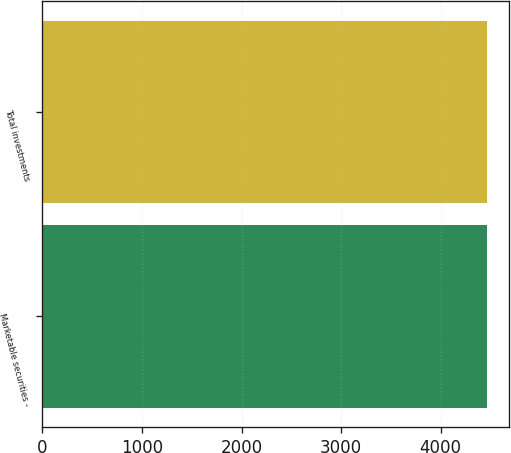<chart> <loc_0><loc_0><loc_500><loc_500><bar_chart><fcel>Marketable securities -<fcel>Total investments<nl><fcel>4467<fcel>4467.1<nl></chart> 